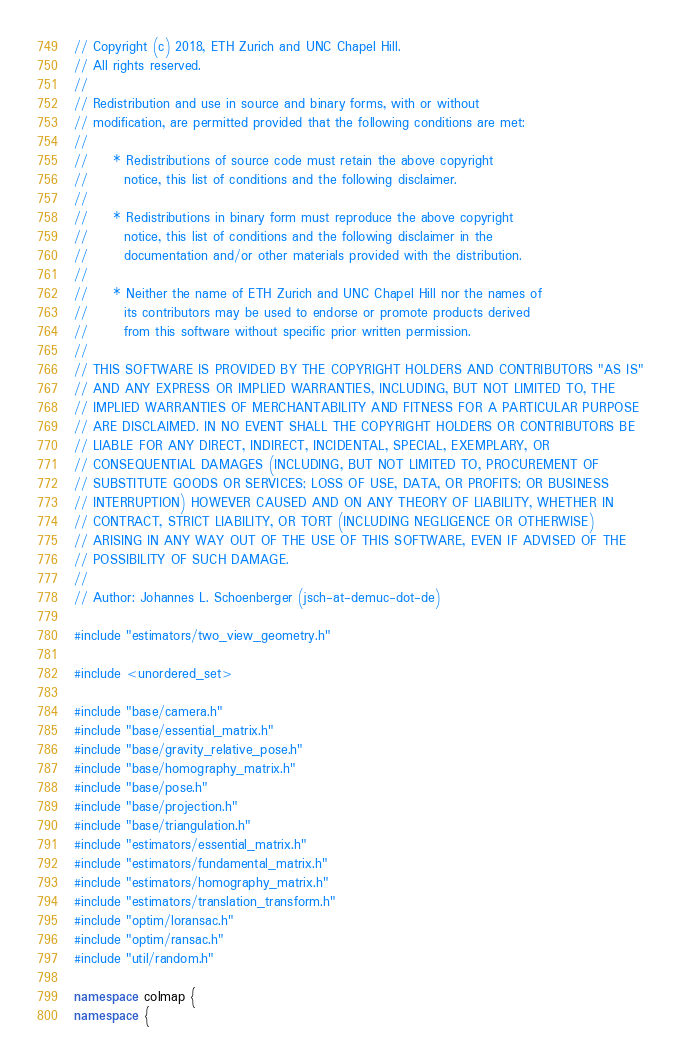<code> <loc_0><loc_0><loc_500><loc_500><_C++_>// Copyright (c) 2018, ETH Zurich and UNC Chapel Hill.
// All rights reserved.
//
// Redistribution and use in source and binary forms, with or without
// modification, are permitted provided that the following conditions are met:
//
//     * Redistributions of source code must retain the above copyright
//       notice, this list of conditions and the following disclaimer.
//
//     * Redistributions in binary form must reproduce the above copyright
//       notice, this list of conditions and the following disclaimer in the
//       documentation and/or other materials provided with the distribution.
//
//     * Neither the name of ETH Zurich and UNC Chapel Hill nor the names of
//       its contributors may be used to endorse or promote products derived
//       from this software without specific prior written permission.
//
// THIS SOFTWARE IS PROVIDED BY THE COPYRIGHT HOLDERS AND CONTRIBUTORS "AS IS"
// AND ANY EXPRESS OR IMPLIED WARRANTIES, INCLUDING, BUT NOT LIMITED TO, THE
// IMPLIED WARRANTIES OF MERCHANTABILITY AND FITNESS FOR A PARTICULAR PURPOSE
// ARE DISCLAIMED. IN NO EVENT SHALL THE COPYRIGHT HOLDERS OR CONTRIBUTORS BE
// LIABLE FOR ANY DIRECT, INDIRECT, INCIDENTAL, SPECIAL, EXEMPLARY, OR
// CONSEQUENTIAL DAMAGES (INCLUDING, BUT NOT LIMITED TO, PROCUREMENT OF
// SUBSTITUTE GOODS OR SERVICES; LOSS OF USE, DATA, OR PROFITS; OR BUSINESS
// INTERRUPTION) HOWEVER CAUSED AND ON ANY THEORY OF LIABILITY, WHETHER IN
// CONTRACT, STRICT LIABILITY, OR TORT (INCLUDING NEGLIGENCE OR OTHERWISE)
// ARISING IN ANY WAY OUT OF THE USE OF THIS SOFTWARE, EVEN IF ADVISED OF THE
// POSSIBILITY OF SUCH DAMAGE.
//
// Author: Johannes L. Schoenberger (jsch-at-demuc-dot-de)

#include "estimators/two_view_geometry.h"

#include <unordered_set>

#include "base/camera.h"
#include "base/essential_matrix.h"
#include "base/gravity_relative_pose.h"
#include "base/homography_matrix.h"
#include "base/pose.h"
#include "base/projection.h"
#include "base/triangulation.h"
#include "estimators/essential_matrix.h"
#include "estimators/fundamental_matrix.h"
#include "estimators/homography_matrix.h"
#include "estimators/translation_transform.h"
#include "optim/loransac.h"
#include "optim/ransac.h"
#include "util/random.h"

namespace colmap {
namespace {
</code> 